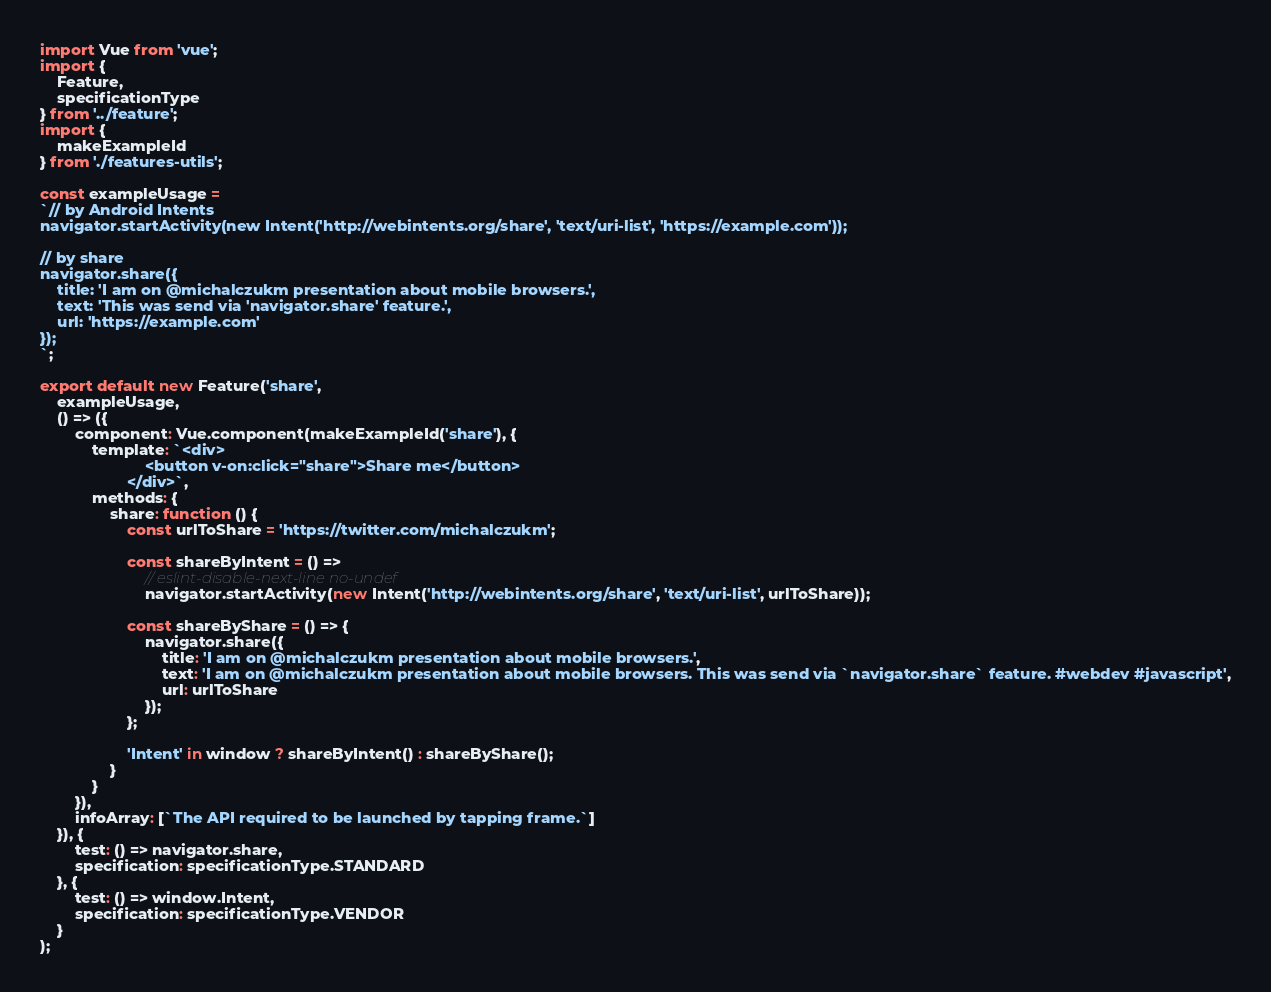<code> <loc_0><loc_0><loc_500><loc_500><_JavaScript_>import Vue from 'vue';
import {
    Feature,
    specificationType
} from '../feature';
import {
    makeExampleId
} from './features-utils';

const exampleUsage =
`// by Android Intents
navigator.startActivity(new Intent('http://webintents.org/share', 'text/uri-list', 'https://example.com'));

// by share
navigator.share({
    title: 'I am on @michalczukm presentation about mobile browsers.',
    text: 'This was send via 'navigator.share' feature.',
    url: 'https://example.com'
});
`;

export default new Feature('share',
    exampleUsage,
    () => ({
        component: Vue.component(makeExampleId('share'), {
            template: `<div>
                        <button v-on:click="share">Share me</button>
                    </div>`,
            methods: {
                share: function () {
                    const urlToShare = 'https://twitter.com/michalczukm';

                    const shareByIntent = () =>
                        // eslint-disable-next-line no-undef
                        navigator.startActivity(new Intent('http://webintents.org/share', 'text/uri-list', urlToShare));

                    const shareByShare = () => {
                        navigator.share({
                            title: 'I am on @michalczukm presentation about mobile browsers.',
                            text: 'I am on @michalczukm presentation about mobile browsers. This was send via `navigator.share` feature. #webdev #javascript',
                            url: urlToShare
                        });
                    };

                    'Intent' in window ? shareByIntent() : shareByShare();
                }
            }
        }),
        infoArray: [`The API required to be launched by tapping frame.`]
    }), {
        test: () => navigator.share,
        specification: specificationType.STANDARD
    }, {
        test: () => window.Intent,
        specification: specificationType.VENDOR
    }
);
</code> 